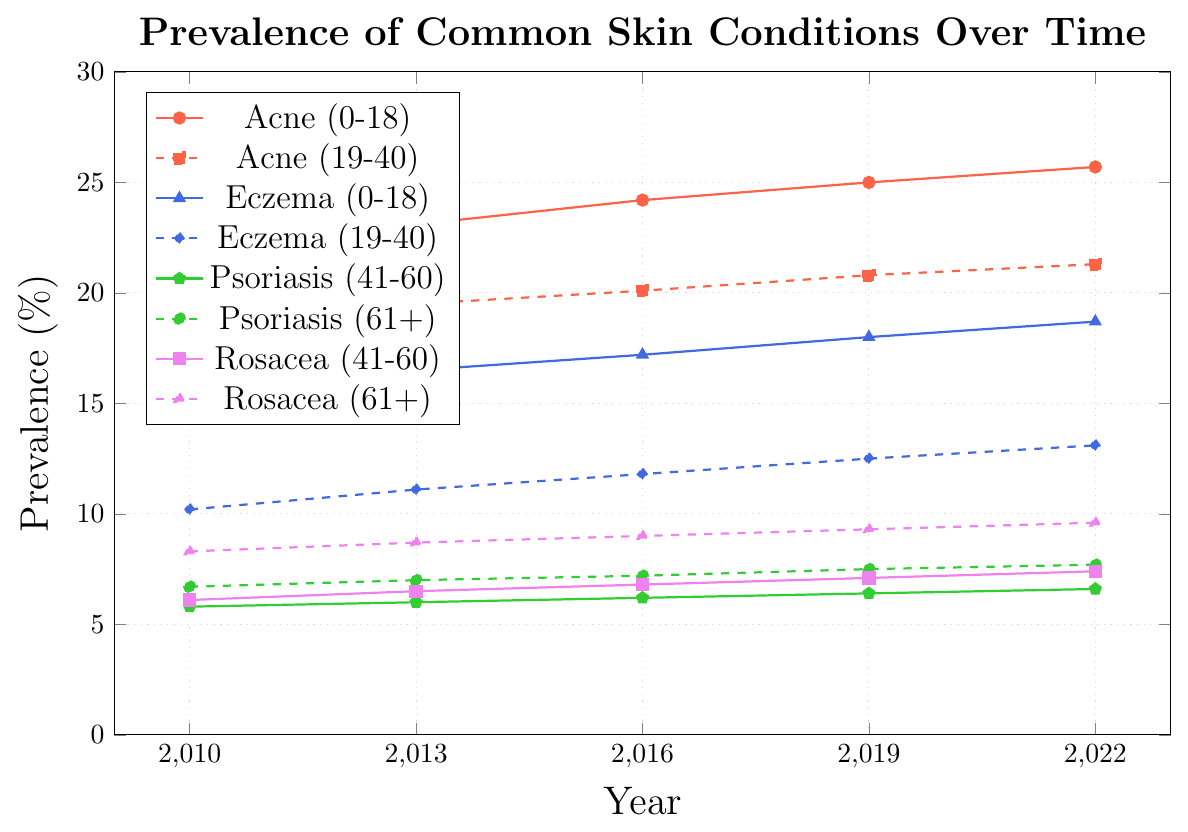What age group has the highest prevalence of Acne in 2022? Look for the prevalence values of Acne in 2022 for all age groups. Compare values: 0-18 (25.7), 19-40 (21.3), 41-60 (11.1), 61+ (3.9). The highest is 0-18 years.
Answer: 0-18 years Has the prevalence of Psoriasis in the 61+ age group increased or decreased from 2010 to 2022? Look at the prevalence values for Psoriasis in the 61+ age group in 2010 (6.7) and in 2022 (7.7). Since 7.7 is greater than 6.7, it has increased.
Answer: Increased What is the difference in the prevalence of Eczema between the 0-18 and 19-40 age groups in 2022? Subtract the prevalence of Eczema in the 19-40 age group (13.1) from the prevalence in the 0-18 age group (18.7) in 2022. 18.7 - 13.1 = 5.6.
Answer: 5.6 Which skin condition has shown the largest absolute increase in prevalence for the 0-18 age group from 2010 to 2022? Calculate the change for each condition from 2010 to 2022 for the 0-18 age group. Acne: 22.3 to 25.7 (+3.4), Eczema: 15.8 to 18.7 (+2.9), Psoriasis and Rosacea have much smaller prevalence. The largest increase is for Acne.
Answer: Acne Between 2010 and 2022, which condition and age group has the smallest overall increase in prevalence? Calculate the change in prevalence for each condition and age group: Acne (3.4 for 0-18, 2.6 for 19-40), Eczema (2.9 for 0-18, 2.9 for 19-40), Psoriasis (0.4 for 41-60, 1.0 for 61+), Rosacea (1.3 for 41-60, 1.3 for 61+). The smallest increase is Psoriasis for 41-60 (0.4).
Answer: Psoriasis (41-60) Compare the trend of Rosacea prevalence between the 41-60 and 61+ age groups from 2010 to 2022. What do you observe? Look at the trends of Rosacea for both 41-60 and 61+ groups. Both groups show an increasing trend, but the trajectory for 61+ is higher starting from 8.3 in 2010 to 9.6 in 2022, while 41-60 goes from 6.1 to 7.4. Both trends indicate a steady increase, with the increase being more prominent in the 61+ group.
Answer: Increasing for both, more prominent in the 61+ group What was the prevalence of Eczema for the age group 19-40 in 2016? Find the prevalence value of Eczema for the 19-40 age group in 2016 from the chart. The value is 11.8.
Answer: 11.8 